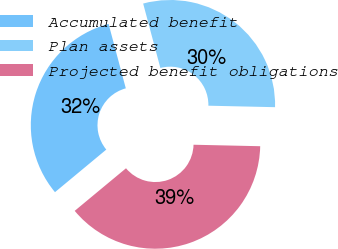<chart> <loc_0><loc_0><loc_500><loc_500><pie_chart><fcel>Accumulated benefit<fcel>Plan assets<fcel>Projected benefit obligations<nl><fcel>31.87%<fcel>29.51%<fcel>38.62%<nl></chart> 